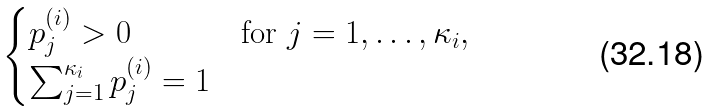Convert formula to latex. <formula><loc_0><loc_0><loc_500><loc_500>\begin{cases} p ^ { ( i ) } _ { j } > 0 & \text {for $j=1,\dotsc,\kappa_{i}$} , \\ \sum _ { j = 1 } ^ { \kappa _ { i } } p ^ { ( i ) } _ { j } = 1 \end{cases}</formula> 